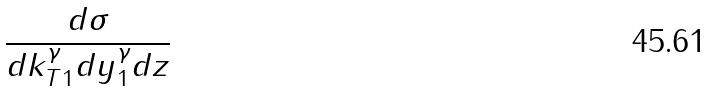Convert formula to latex. <formula><loc_0><loc_0><loc_500><loc_500>\frac { d \sigma } { d k _ { T 1 } ^ { \gamma } d y ^ { \gamma } _ { 1 } d z }</formula> 